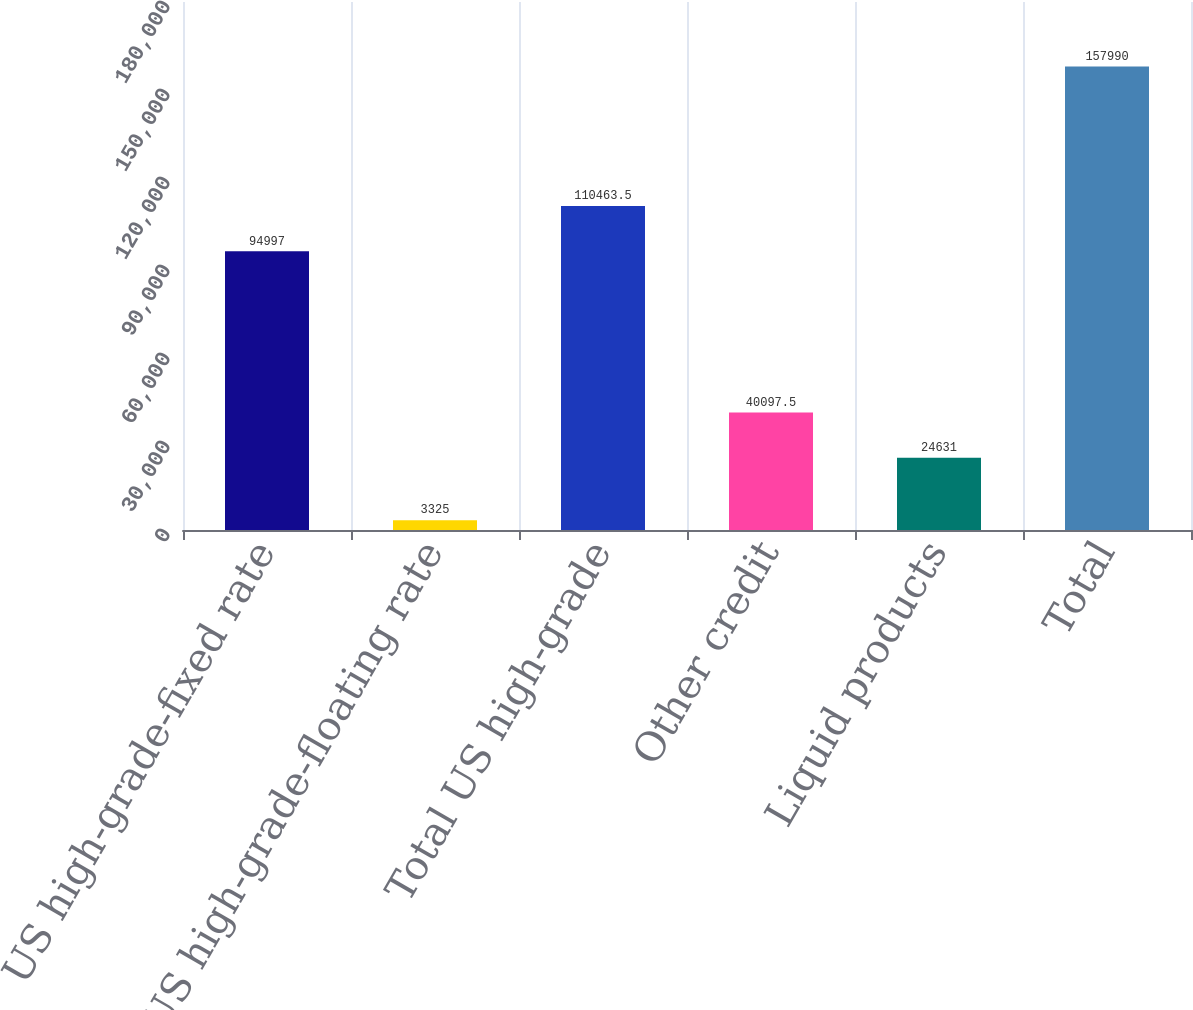Convert chart. <chart><loc_0><loc_0><loc_500><loc_500><bar_chart><fcel>US high-grade-fixed rate<fcel>US high-grade-floating rate<fcel>Total US high-grade<fcel>Other credit<fcel>Liquid products<fcel>Total<nl><fcel>94997<fcel>3325<fcel>110464<fcel>40097.5<fcel>24631<fcel>157990<nl></chart> 